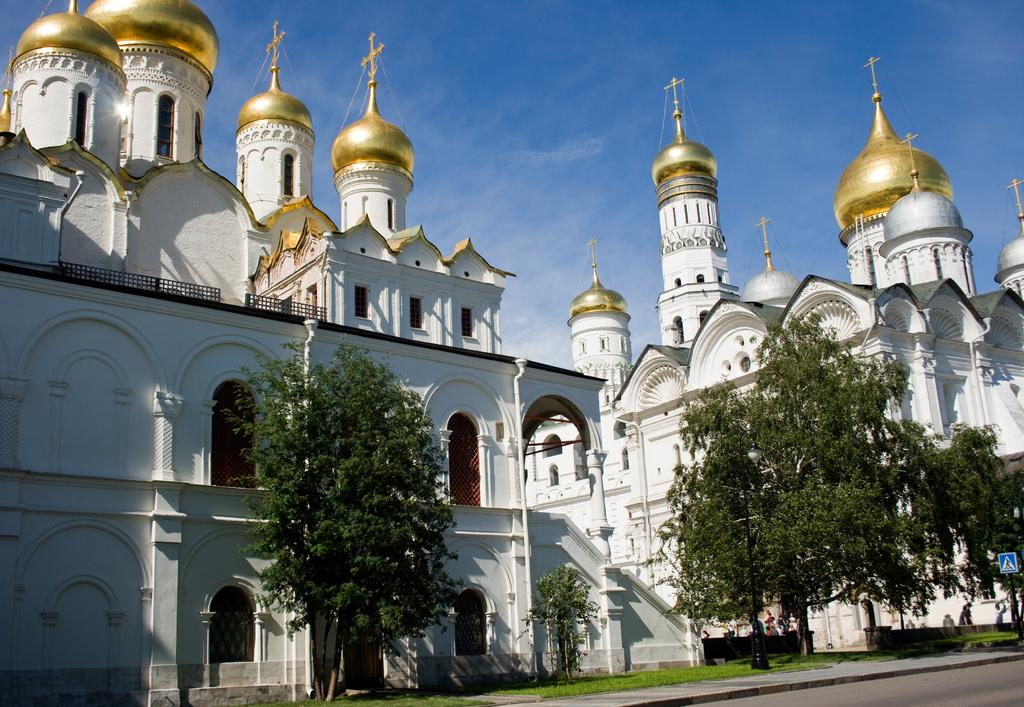What type of building is in the image? There is a church in the image. What type of vegetation is present in the image? There are trees in the image. What is visible at the top of the image? The sky is visible at the top of the image. What is located at the bottom of the image? There is a road and grass at the bottom of the image. How many cars are parked near the church in the image? There are no cars present in the image; it only features a church, trees, the sky, a road, and grass. 